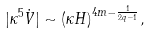<formula> <loc_0><loc_0><loc_500><loc_500>| \kappa ^ { 5 } \dot { V } | \sim ( \kappa H ) ^ { 4 m - \frac { 1 } { 2 q - 1 } } ,</formula> 